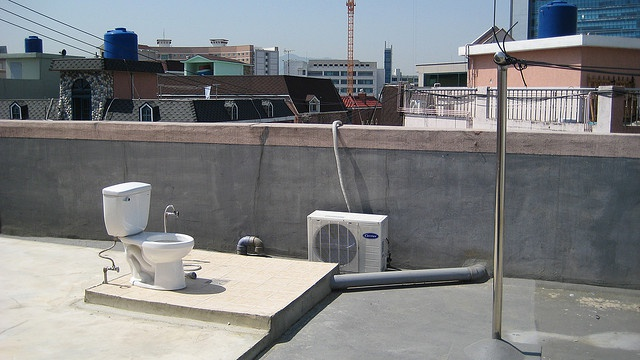Describe the objects in this image and their specific colors. I can see a toilet in darkgray, lightgray, and gray tones in this image. 